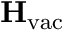Convert formula to latex. <formula><loc_0><loc_0><loc_500><loc_500>H _ { v a c }</formula> 